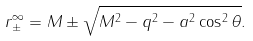Convert formula to latex. <formula><loc_0><loc_0><loc_500><loc_500>r ^ { \infty } _ { \pm } = M \pm \sqrt { M ^ { 2 } - q ^ { 2 } - a ^ { 2 } \cos ^ { 2 } \theta } .</formula> 